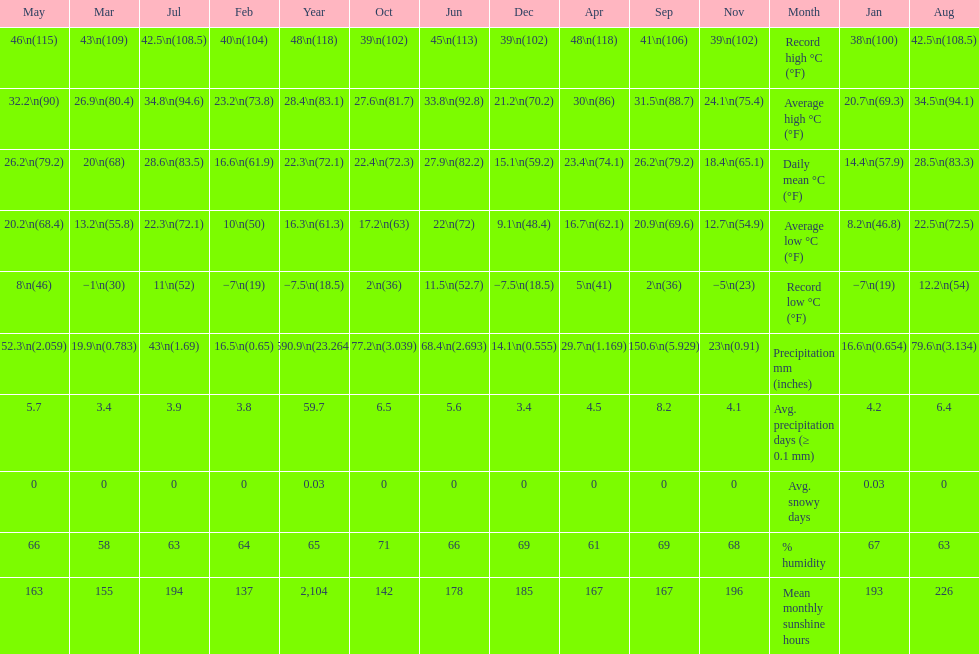Which month had a record high temperature of 100 degrees fahrenheit and also a record low temperature of 19 degrees fahrenheit? January. 